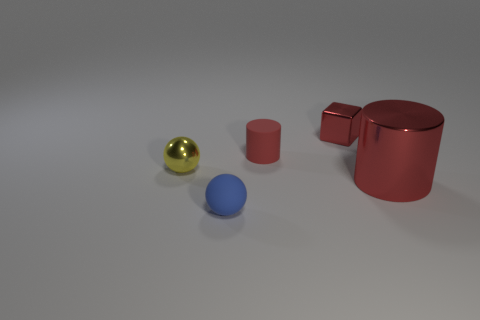Is there a object made of the same material as the tiny yellow sphere?
Give a very brief answer. Yes. Are there fewer small blue rubber objects on the left side of the tiny yellow thing than big brown cylinders?
Offer a terse response. No. What material is the red cylinder that is in front of the ball that is behind the small blue ball made of?
Provide a succinct answer. Metal. The thing that is behind the yellow object and on the left side of the tiny metallic cube has what shape?
Your response must be concise. Cylinder. What number of other things are the same color as the small cylinder?
Offer a very short reply. 2. How many things are either tiny spheres on the right side of the yellow sphere or red metallic things?
Offer a terse response. 3. Do the small cube and the cylinder behind the tiny yellow sphere have the same color?
Ensure brevity in your answer.  Yes. Is there anything else that is the same size as the red metallic cylinder?
Provide a succinct answer. No. There is a cylinder that is on the right side of the red cylinder that is left of the block; what is its size?
Ensure brevity in your answer.  Large. How many things are tiny red shiny things or shiny objects that are in front of the tiny metal cube?
Offer a very short reply. 3. 